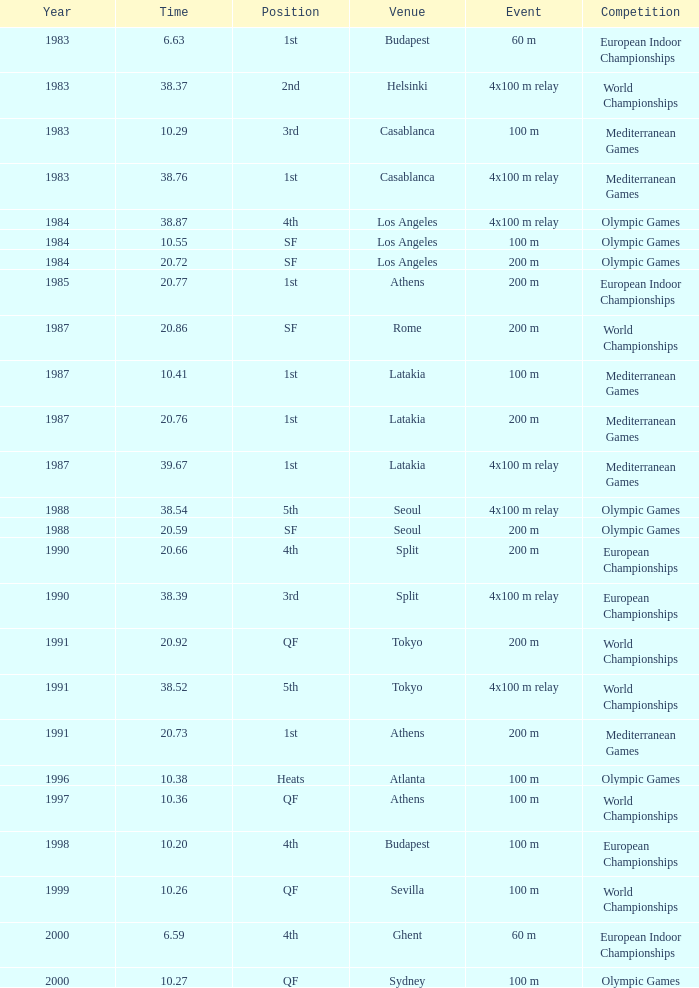What Position has a Time of 20.66? 4th. 